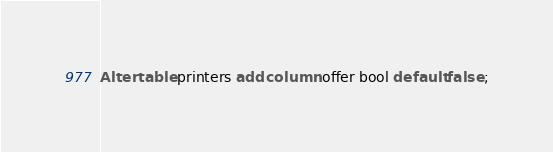Convert code to text. <code><loc_0><loc_0><loc_500><loc_500><_SQL_>Alter table printers add column offer bool default false ;

</code> 